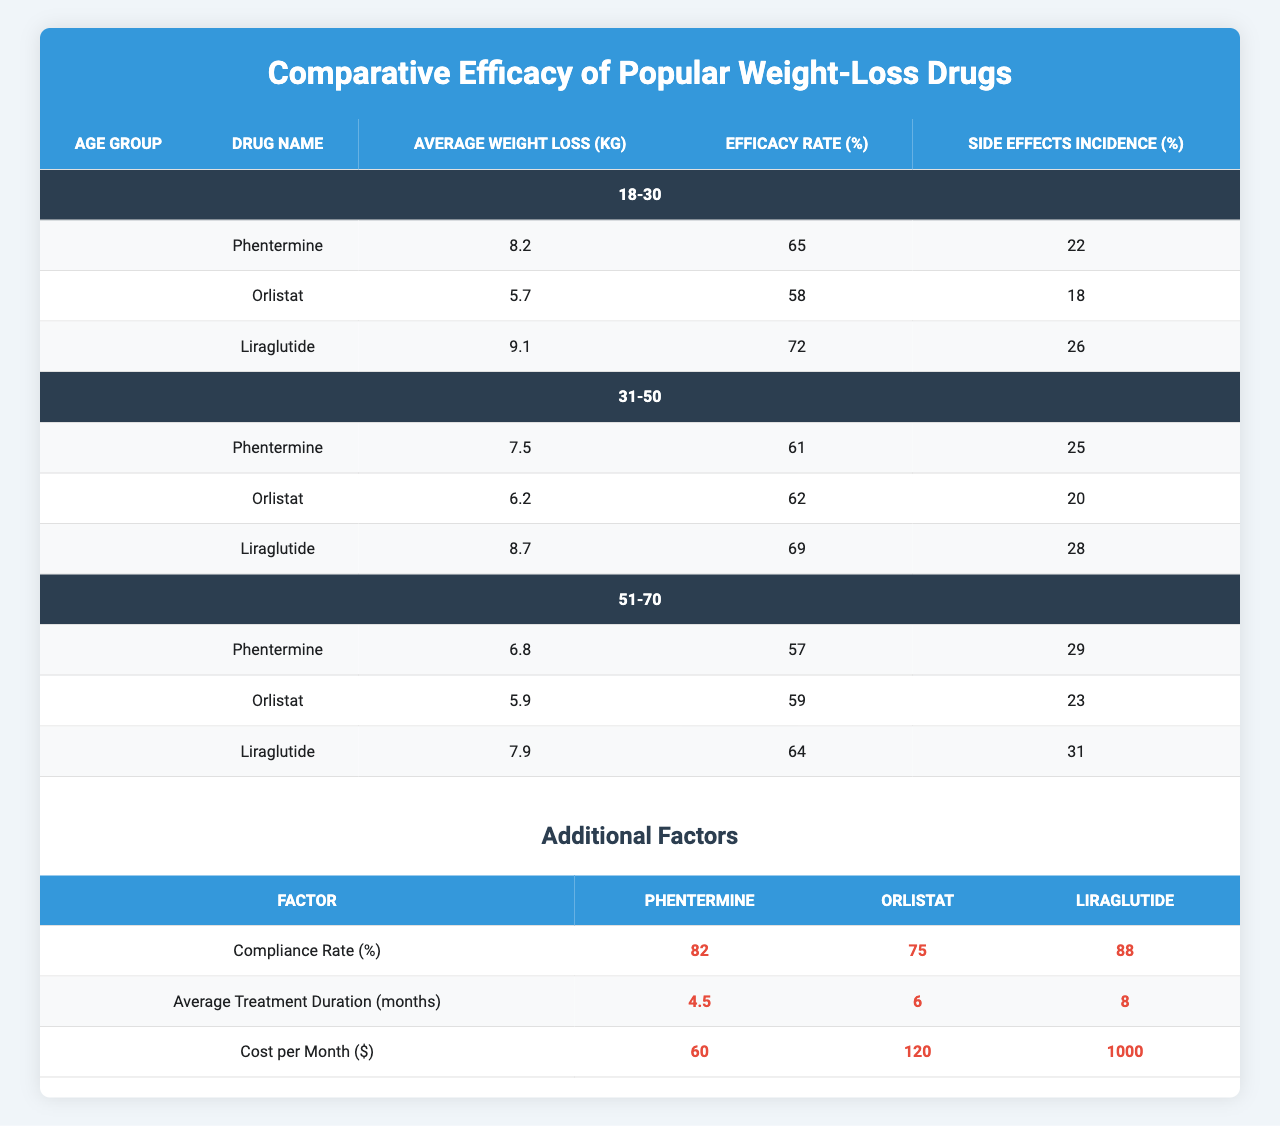What is the average weight loss for Liraglutide in the 31-50 age group? The average weight loss for Liraglutide in the 31-50 age group is directly listed in the table as 8.7 kg.
Answer: 8.7 kg What percentage of individuals experienced side effects when taking Orlistat in the 51-70 age group? The table shows that the side effects incidence for Orlistat in the 51-70 age group is 23%.
Answer: 23% Which drug has the highest efficacy rate in the 18-30 age group? From the data in the table, Liraglutide has the highest efficacy rate at 72%.
Answer: Liraglutide How much greater is the average weight loss for Phentermine compared to Orlistat in the 31-50 age group? The average weight loss for Phentermine is 7.5 kg and Orlistat is 6.2 kg. The difference is 7.5 - 6.2 = 1.3 kg.
Answer: 1.3 kg Is the compliance rate for Liraglutide higher than that for Phentermine? The compliance rate for Liraglutide is 88%, while for Phentermine it is 82%. Since 88% is greater than 82%, the statement is true.
Answer: Yes What is the cost per month for all three drugs combined? The cost per month for Phentermine is $60, for Orlistat is $120, and for Liraglutide is $1000. Adding these gives $60 + $120 + $1000 = $1180.
Answer: $1180 In which age group does Phentermine exhibit the lowest efficacy rate? The data shows that in the 51-70 age group, Phentermine has the lowest efficacy rate at 57%.
Answer: 51-70 age group Which drug has the least side effects incidence overall? Evaluating the side effect incidences: Phentermine has 22%, 25%, and 29%; Orlistat has 18%, 20%, and 23%; Liraglutide has 26%, 28%, and 31%. The least incidence percentage belongs to Orlistat with 18%.
Answer: Orlistat What is the average efficacy rate of all drugs in the 51-70 age group? Phentermine has 57%, Orlistat has 59%, and Liraglutide has 64%. So, the average is (57 + 59 + 64) / 3 = 60.
Answer: 60% If a patient in the 18-30 age group wants to lose at least 9 kg, which drug would they likely choose based on the average weight loss data? The average weight loss for each drug is Phentermine at 8.2 kg, Orlistat at 5.7 kg, and Liraglutide at 9.1 kg. Liraglutide is the only option whose average weight loss meets or exceeds 9 kg.
Answer: Liraglutide 